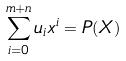Convert formula to latex. <formula><loc_0><loc_0><loc_500><loc_500>\sum _ { i = 0 } ^ { m + n } u _ { i } x ^ { i } = P ( X )</formula> 